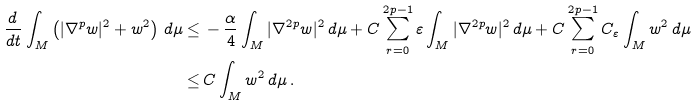Convert formula to latex. <formula><loc_0><loc_0><loc_500><loc_500>\frac { d \, } { d t } \int _ { M } \left ( | \nabla ^ { p } w | ^ { 2 } + w ^ { 2 } \right ) \, d \mu \leq & \, - \frac { \alpha } { 4 } \int _ { M } | \nabla ^ { 2 p } w | ^ { 2 } \, d \mu + C \sum _ { r = 0 } ^ { 2 p - 1 } \varepsilon \int _ { M } | \nabla ^ { 2 p } w | ^ { 2 } \, d \mu + C \sum _ { r = 0 } ^ { 2 p - 1 } C _ { \varepsilon } \int _ { M } w ^ { 2 } \, d \mu \\ \leq & \, C \int _ { M } w ^ { 2 } \, d \mu \, .</formula> 